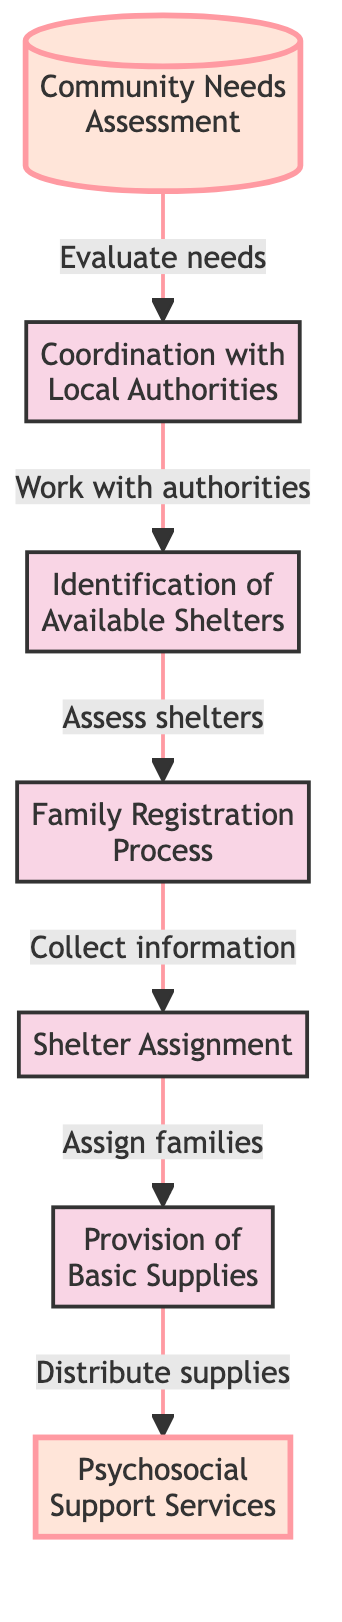What is the first step in the emergency shelter process? The first step shown in the flow chart is the "Community Needs Assessment," which evaluates the number of families in need of emergency shelter.
Answer: Community Needs Assessment How many main steps are there in the emergency shelter process? By counting the distinct boxes in the flowchart, we find there are seven main steps represented.
Answer: 7 What is the outcome of the "Family Registration Process"? The outcome of the "Family Registration Process" is the "Shelter Assignment," where families are assigned to appropriate shelters based on their needs.
Answer: Shelter Assignment Which step involves distributing food and hygiene kits? The step that involves distributing food, water, and hygiene kits is "Provision of Basic Supplies," which takes place after families are assigned to shelters.
Answer: Provision of Basic Supplies What kind of support is provided after families receive shelter? After families receive shelter, "Psychosocial Support Services" are provided to offer emotional and psychological support affected by conflict.
Answer: Psychosocial Support Services Which two steps are highlighted in the diagram? The highlighted steps in the diagram are "Community Needs Assessment" and "Psychosocial Support Services," indicating their significance in the process.
Answer: Community Needs Assessment, Psychosocial Support Services What process follows the evaluation of community needs? The process that follows the evaluation of community needs is "Coordination with Local Authorities," where efforts are made to work with local governments and NGOs.
Answer: Coordination with Local Authorities Which step comes before "Shelter Assignment"? The step that comes before "Shelter Assignment" is the "Family Registration Process," where information about each family's needs and members is collected.
Answer: Family Registration Process 